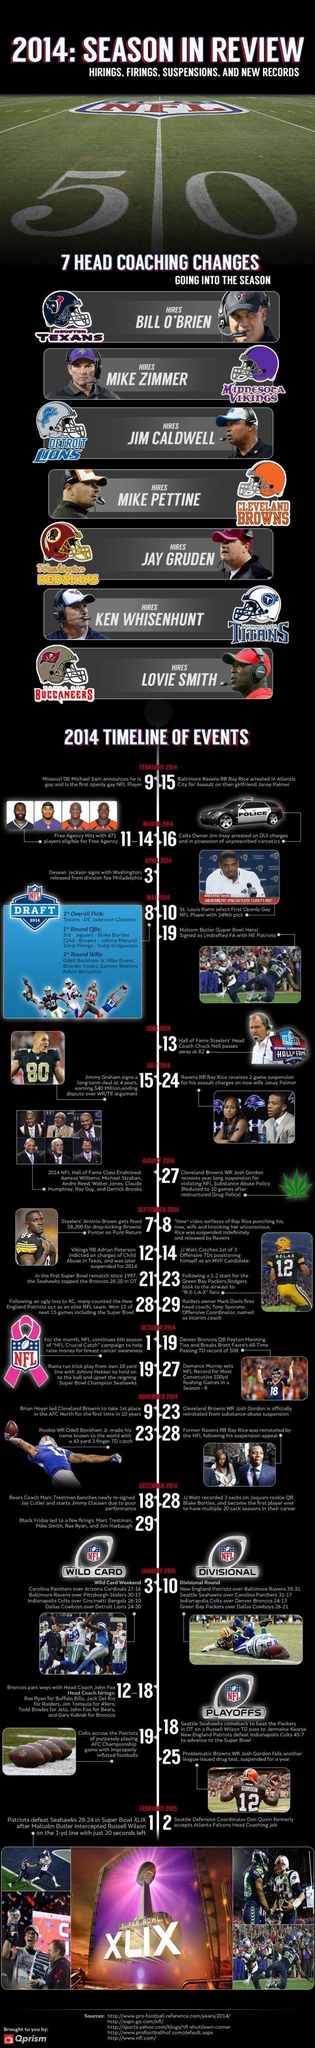When was the Super Bowl XLIX game played?
Answer the question with a short phrase. FEBRUARY 2015 Who was the head coach of Minnesota Vikings in the 2014 NFL season? MIKE ZIMMER Which NFL team hired Jay Gruden as the head coach in the 2014 NFL season? Washington Redskins 